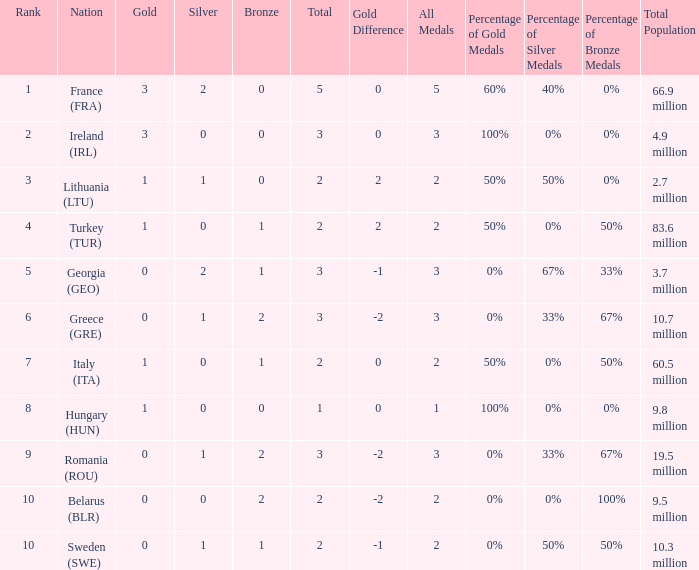Could you parse the entire table? {'header': ['Rank', 'Nation', 'Gold', 'Silver', 'Bronze', 'Total', 'Gold Difference', 'All Medals', 'Percentage of Gold Medals', 'Percentage of Silver Medals', 'Percentage of Bronze Medals', 'Total Population'], 'rows': [['1', 'France (FRA)', '3', '2', '0', '5', '0', '5', '60%', '40%', '0%', '66.9 million'], ['2', 'Ireland (IRL)', '3', '0', '0', '3', '0', '3', '100%', '0%', '0%', '4.9 million'], ['3', 'Lithuania (LTU)', '1', '1', '0', '2', '2', '2', '50%', '50%', '0%', '2.7 million'], ['4', 'Turkey (TUR)', '1', '0', '1', '2', '2', '2', '50%', '0%', '50%', '83.6 million'], ['5', 'Georgia (GEO)', '0', '2', '1', '3', '-1', '3', '0%', '67%', '33%', '3.7 million'], ['6', 'Greece (GRE)', '0', '1', '2', '3', '-2', '3', '0%', '33%', '67%', '10.7 million'], ['7', 'Italy (ITA)', '1', '0', '1', '2', '0', '2', '50%', '0%', '50%', '60.5 million'], ['8', 'Hungary (HUN)', '1', '0', '0', '1', '0', '1', '100%', '0%', '0%', '9.8 million'], ['9', 'Romania (ROU)', '0', '1', '2', '3', '-2', '3', '0%', '33%', '67%', '19.5 million'], ['10', 'Belarus (BLR)', '0', '0', '2', '2', '-2', '2', '0%', '0%', '100%', '9.5 million'], ['10', 'Sweden (SWE)', '0', '1', '1', '2', '-1', '2', '0%', '50%', '50%', '10.3 million']]} What's the total of Sweden (SWE) having less than 1 silver? None. 